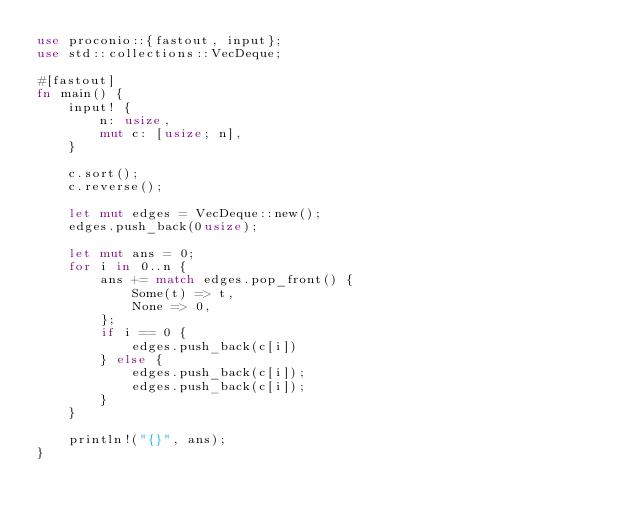<code> <loc_0><loc_0><loc_500><loc_500><_Rust_>use proconio::{fastout, input};
use std::collections::VecDeque;

#[fastout]
fn main() {
    input! {
        n: usize,
        mut c: [usize; n],
    }

    c.sort();
    c.reverse();

    let mut edges = VecDeque::new();
    edges.push_back(0usize);

    let mut ans = 0;
    for i in 0..n {
        ans += match edges.pop_front() {
            Some(t) => t,
            None => 0,
        };
        if i == 0 {
            edges.push_back(c[i])
        } else {
            edges.push_back(c[i]);
            edges.push_back(c[i]);
        }
    }

    println!("{}", ans);
}
</code> 